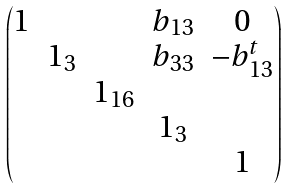<formula> <loc_0><loc_0><loc_500><loc_500>\begin{pmatrix} 1 & & & b _ { 1 3 } & 0 \\ & 1 _ { 3 } & & b _ { 3 3 } & - b _ { 1 3 } ^ { t } \\ & & 1 _ { 1 6 } & & \\ & & & 1 _ { 3 } & \\ & & & & 1 \end{pmatrix}</formula> 